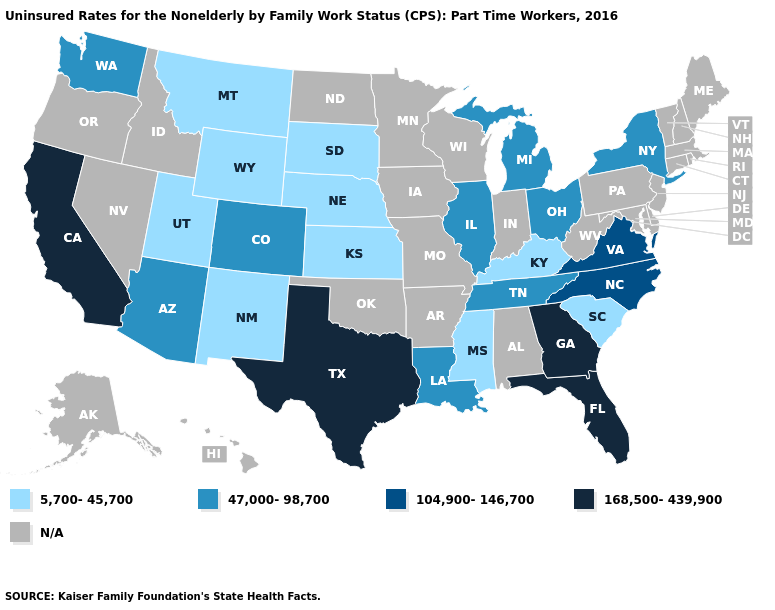What is the value of Kansas?
Keep it brief. 5,700-45,700. Name the states that have a value in the range 5,700-45,700?
Keep it brief. Kansas, Kentucky, Mississippi, Montana, Nebraska, New Mexico, South Carolina, South Dakota, Utah, Wyoming. Name the states that have a value in the range 47,000-98,700?
Be succinct. Arizona, Colorado, Illinois, Louisiana, Michigan, New York, Ohio, Tennessee, Washington. What is the value of Connecticut?
Quick response, please. N/A. Name the states that have a value in the range 168,500-439,900?
Concise answer only. California, Florida, Georgia, Texas. What is the lowest value in the Northeast?
Answer briefly. 47,000-98,700. What is the value of Iowa?
Answer briefly. N/A. Among the states that border Nevada , does Arizona have the lowest value?
Quick response, please. No. Is the legend a continuous bar?
Concise answer only. No. Does Kansas have the highest value in the MidWest?
Keep it brief. No. What is the highest value in the USA?
Short answer required. 168,500-439,900. Name the states that have a value in the range 104,900-146,700?
Be succinct. North Carolina, Virginia. What is the lowest value in the South?
Answer briefly. 5,700-45,700. 